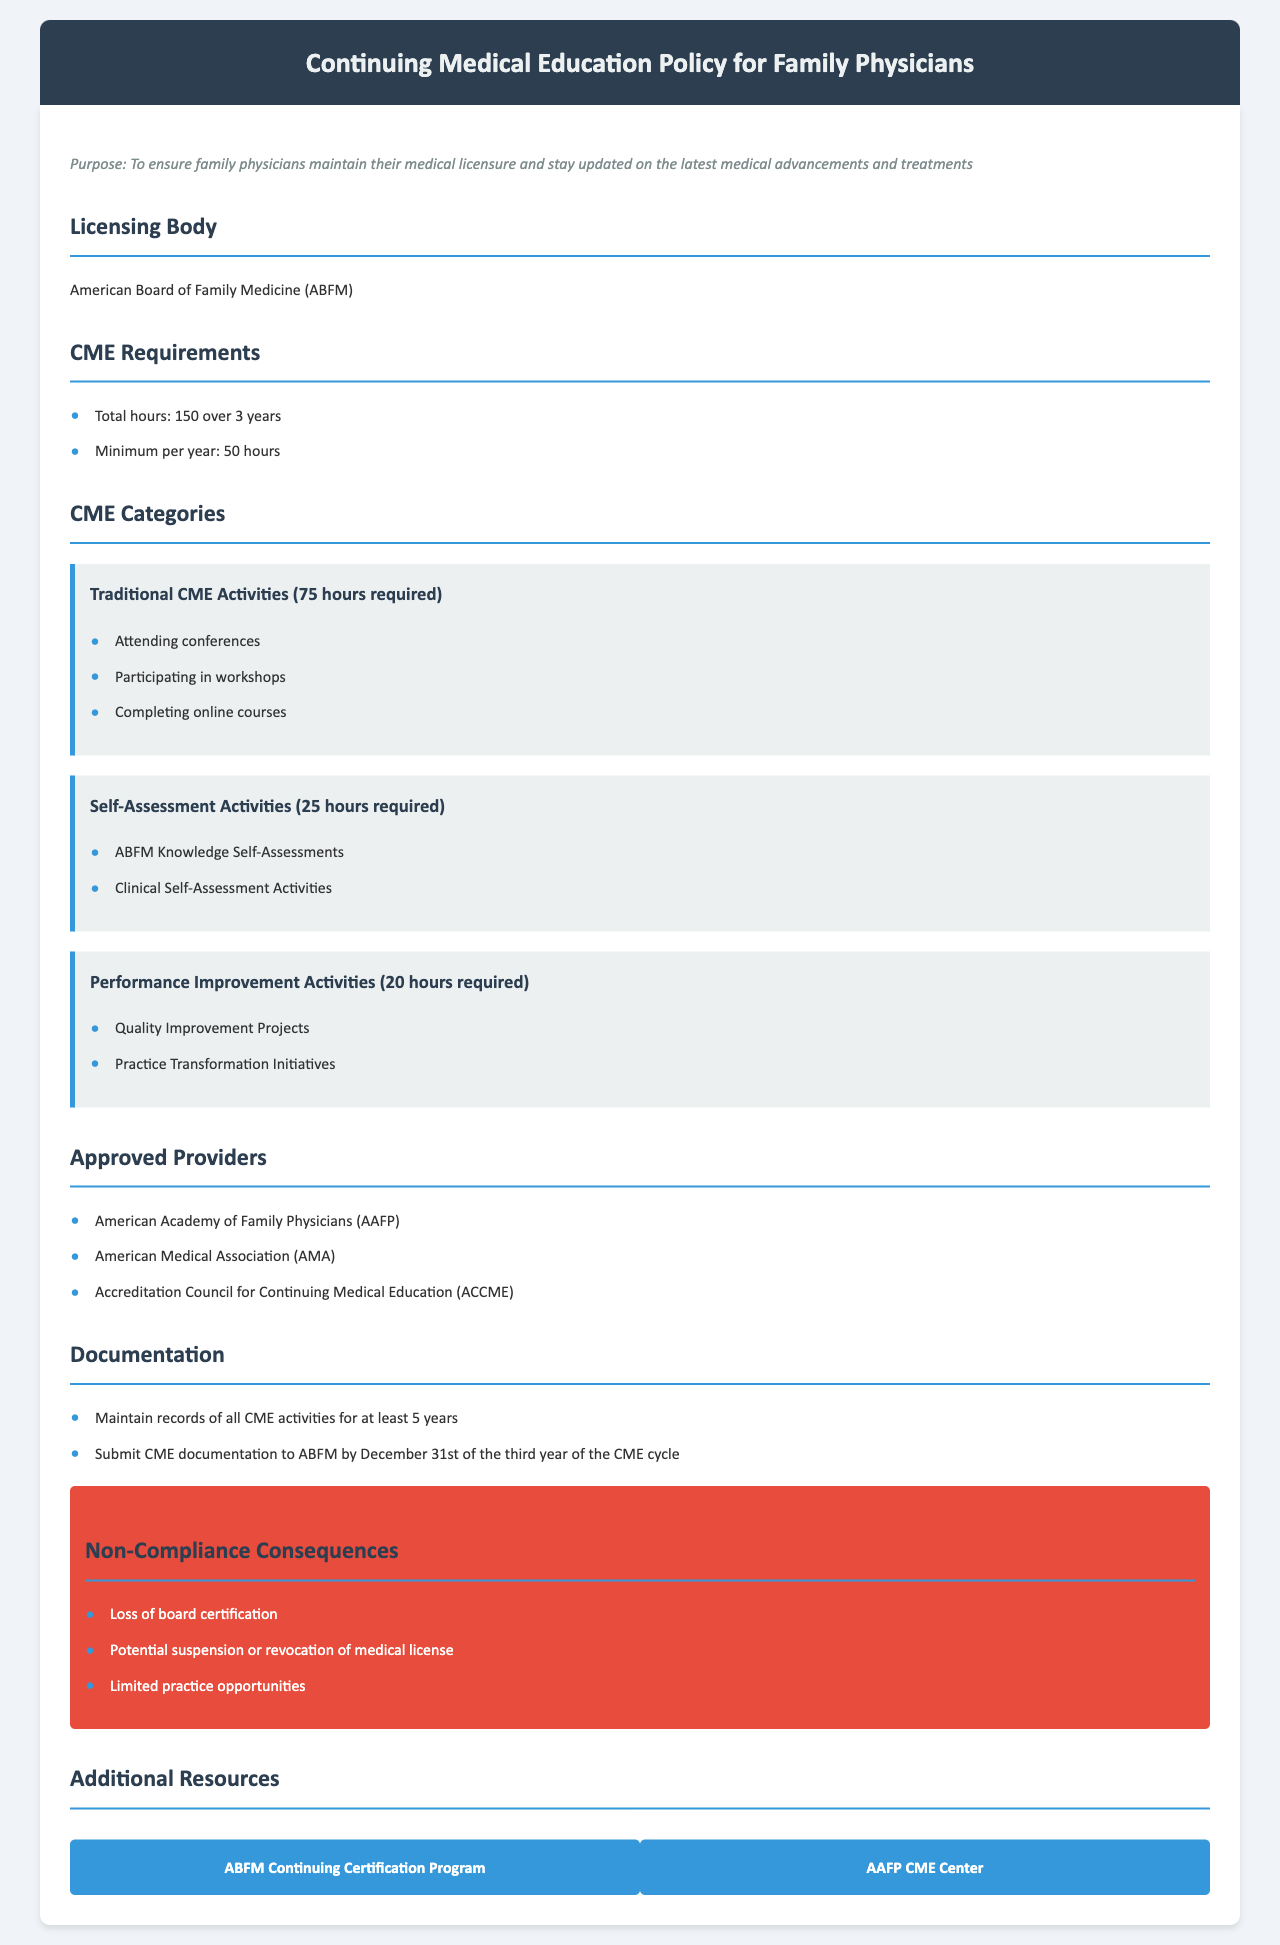What is the total number of CME hours required over 3 years? The total number of CME hours required is stated in the document, which is 150.
Answer: 150 What is the minimum number of CME hours required per year? The document specifies a minimum of 50 hours that family physicians must complete each year.
Answer: 50 hours How many hours of Traditional CME Activities are required? The requirement for Traditional CME Activities is explicitly mentioned in the document as 75 hours.
Answer: 75 hours Which organization is the licensing body mentioned? The document identifies the American Board of Family Medicine as the licensing body.
Answer: American Board of Family Medicine What are the consequences of non-compliance? The document lists several potential consequences of non-compliance, including loss of board certification.
Answer: Loss of board certification What is the deadline for submitting CME documentation? The document states that CME documentation must be submitted to the ABFM by December 31st of the third year of the CME cycle.
Answer: December 31st Name one approved provider for CME activities. The document lists several approved providers, one of which is the American Academy of Family Physicians.
Answer: American Academy of Family Physicians What is the minimum number of hours required for Performance Improvement Activities? The document specifies that 20 hours are required for Performance Improvement Activities.
Answer: 20 hours 